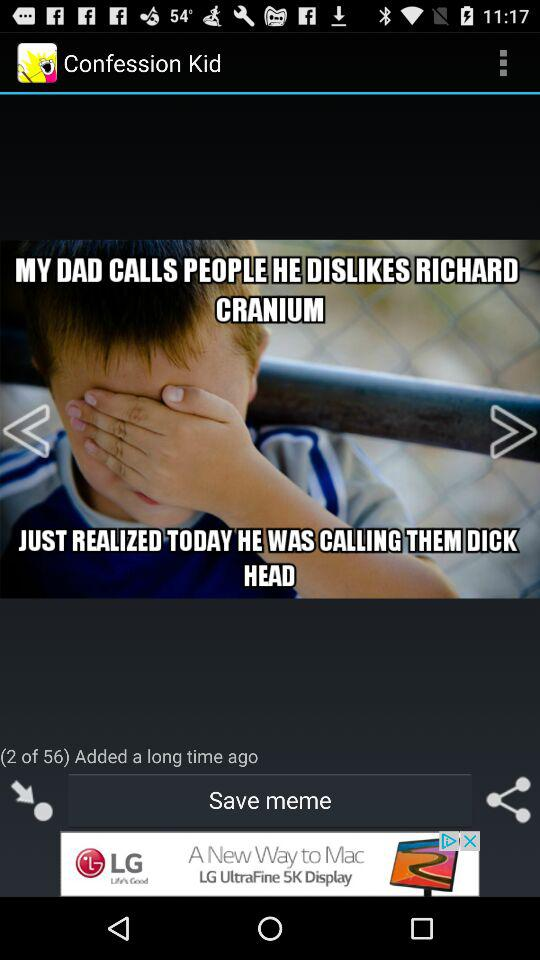How many photos in total are there? There are 56 photos in total. 